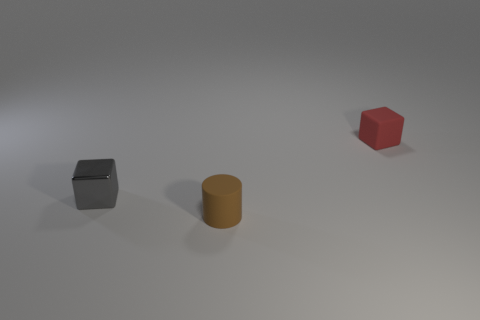Subtract 2 blocks. How many blocks are left? 0 Subtract all red blocks. Subtract all green spheres. How many blocks are left? 1 Subtract all purple spheres. How many purple cylinders are left? 0 Subtract all small objects. Subtract all small blue matte blocks. How many objects are left? 0 Add 1 small red matte blocks. How many small red matte blocks are left? 2 Add 3 tiny blue rubber objects. How many tiny blue rubber objects exist? 3 Add 2 red matte objects. How many objects exist? 5 Subtract all red blocks. How many blocks are left? 1 Subtract 0 yellow balls. How many objects are left? 3 Subtract all cylinders. How many objects are left? 2 